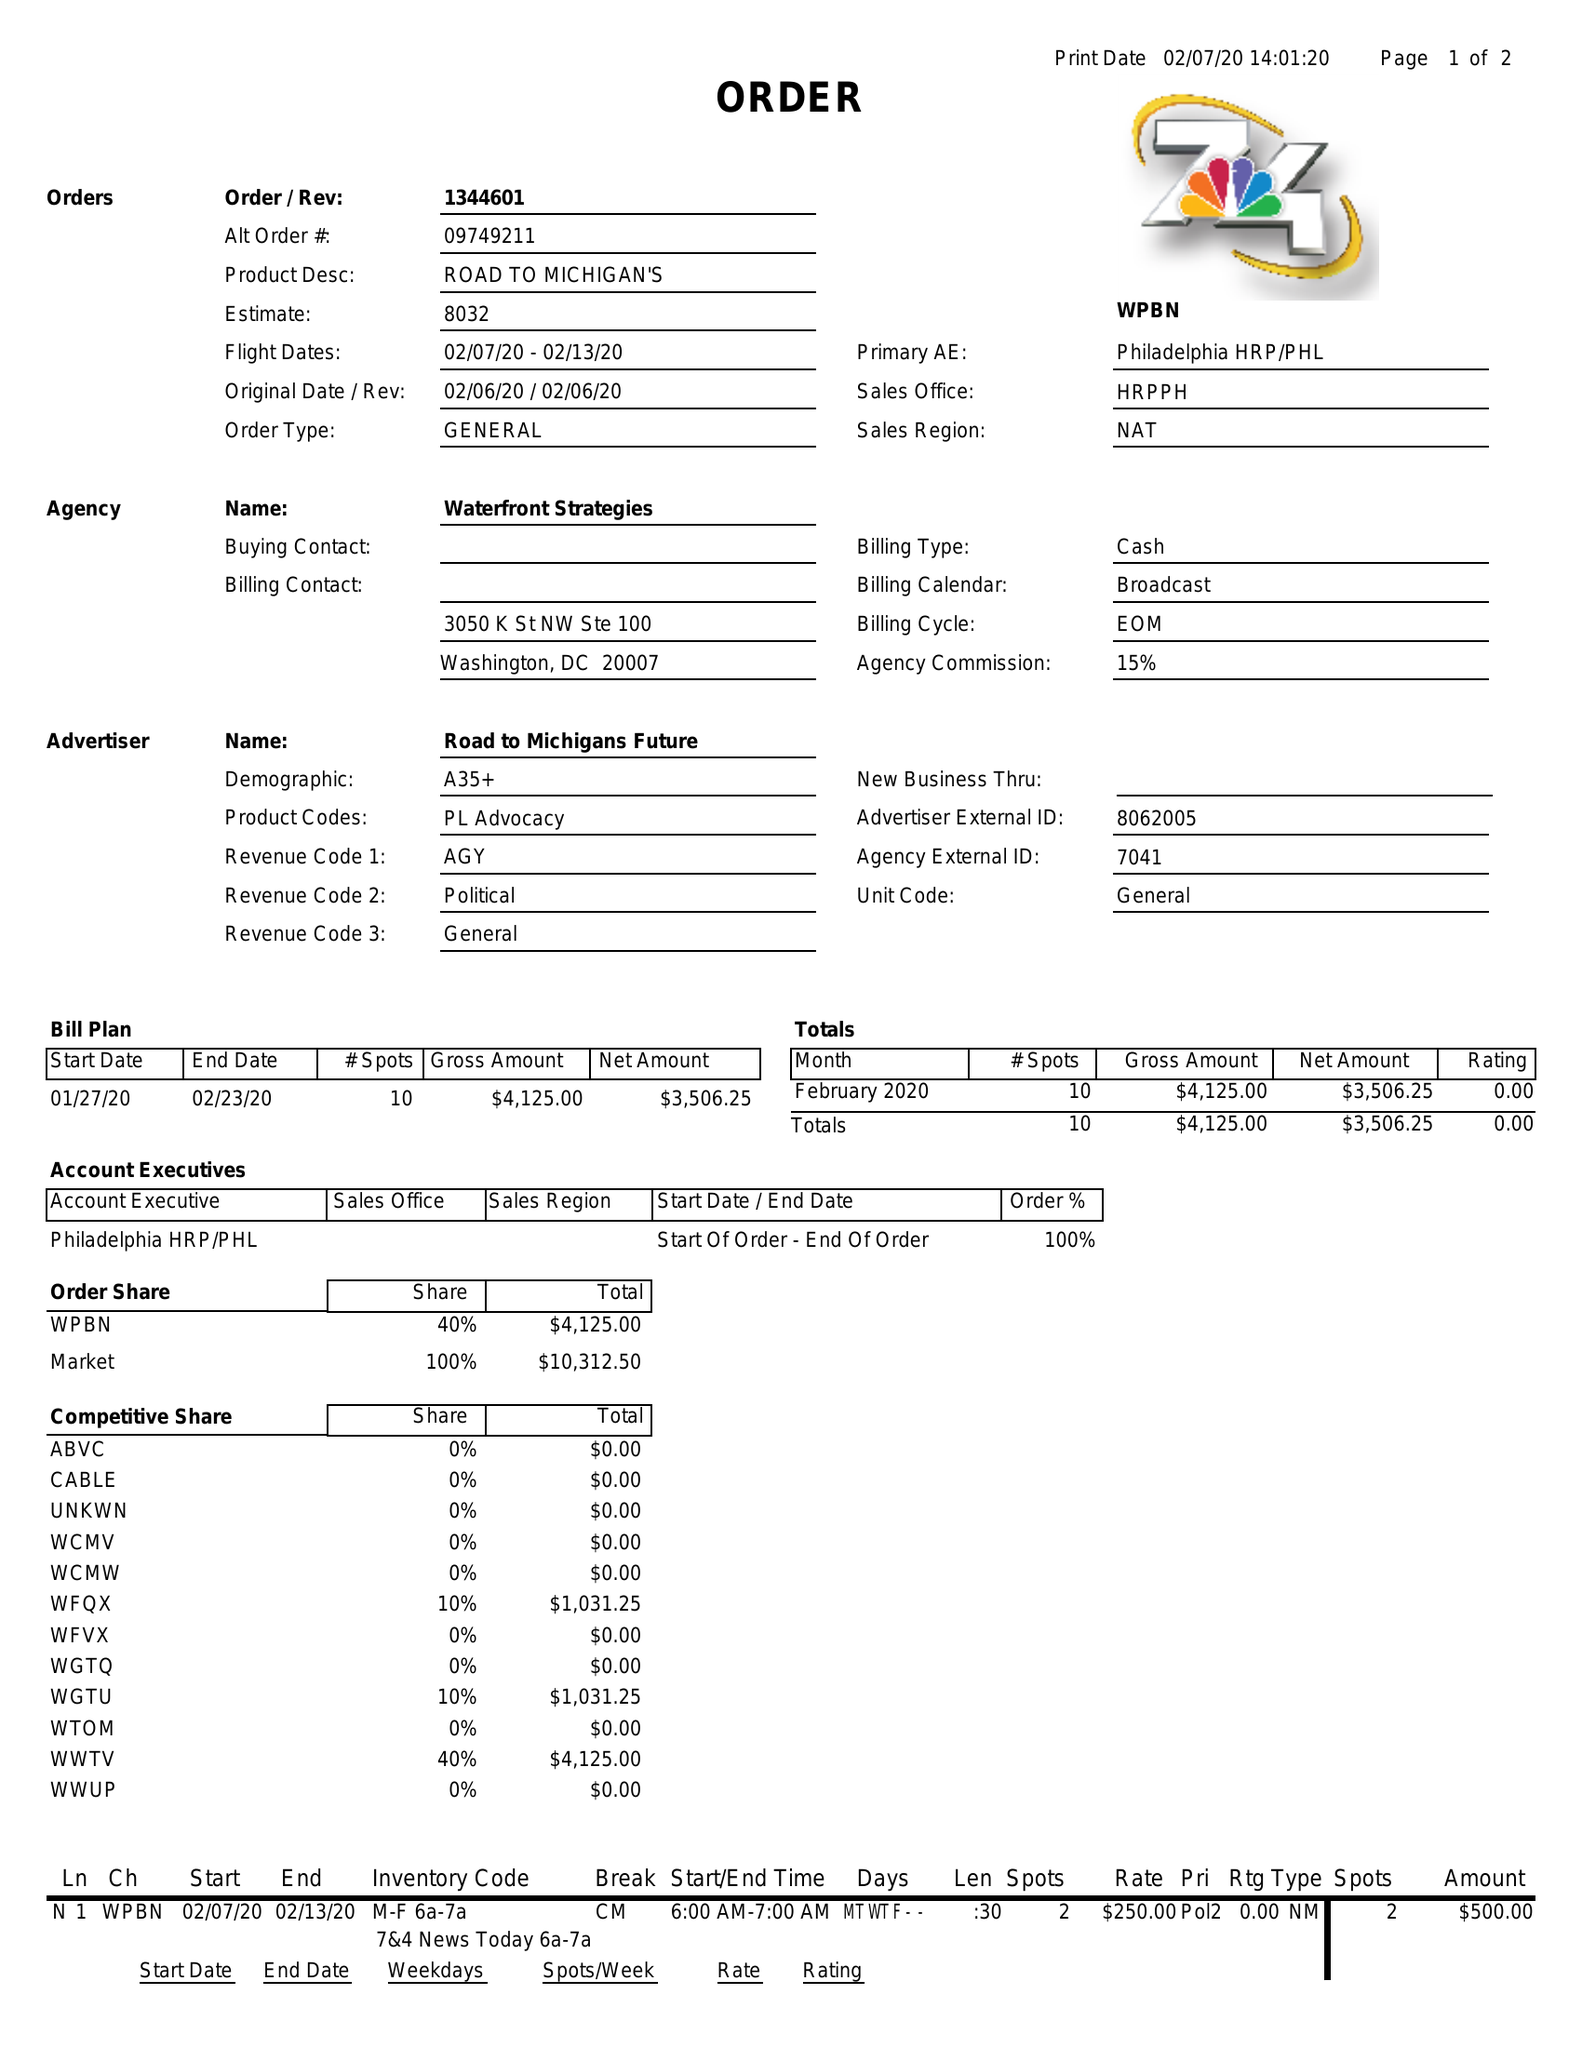What is the value for the flight_to?
Answer the question using a single word or phrase. 02/13/20 